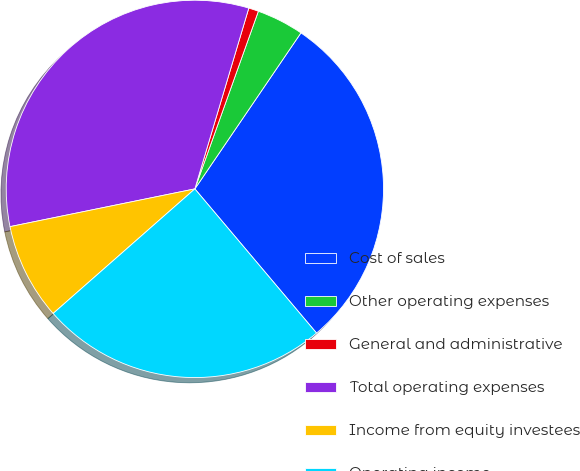Convert chart to OTSL. <chart><loc_0><loc_0><loc_500><loc_500><pie_chart><fcel>Cost of sales<fcel>Other operating expenses<fcel>General and administrative<fcel>Total operating expenses<fcel>Income from equity investees<fcel>Operating income<nl><fcel>29.34%<fcel>4.04%<fcel>0.85%<fcel>32.82%<fcel>8.27%<fcel>24.68%<nl></chart> 